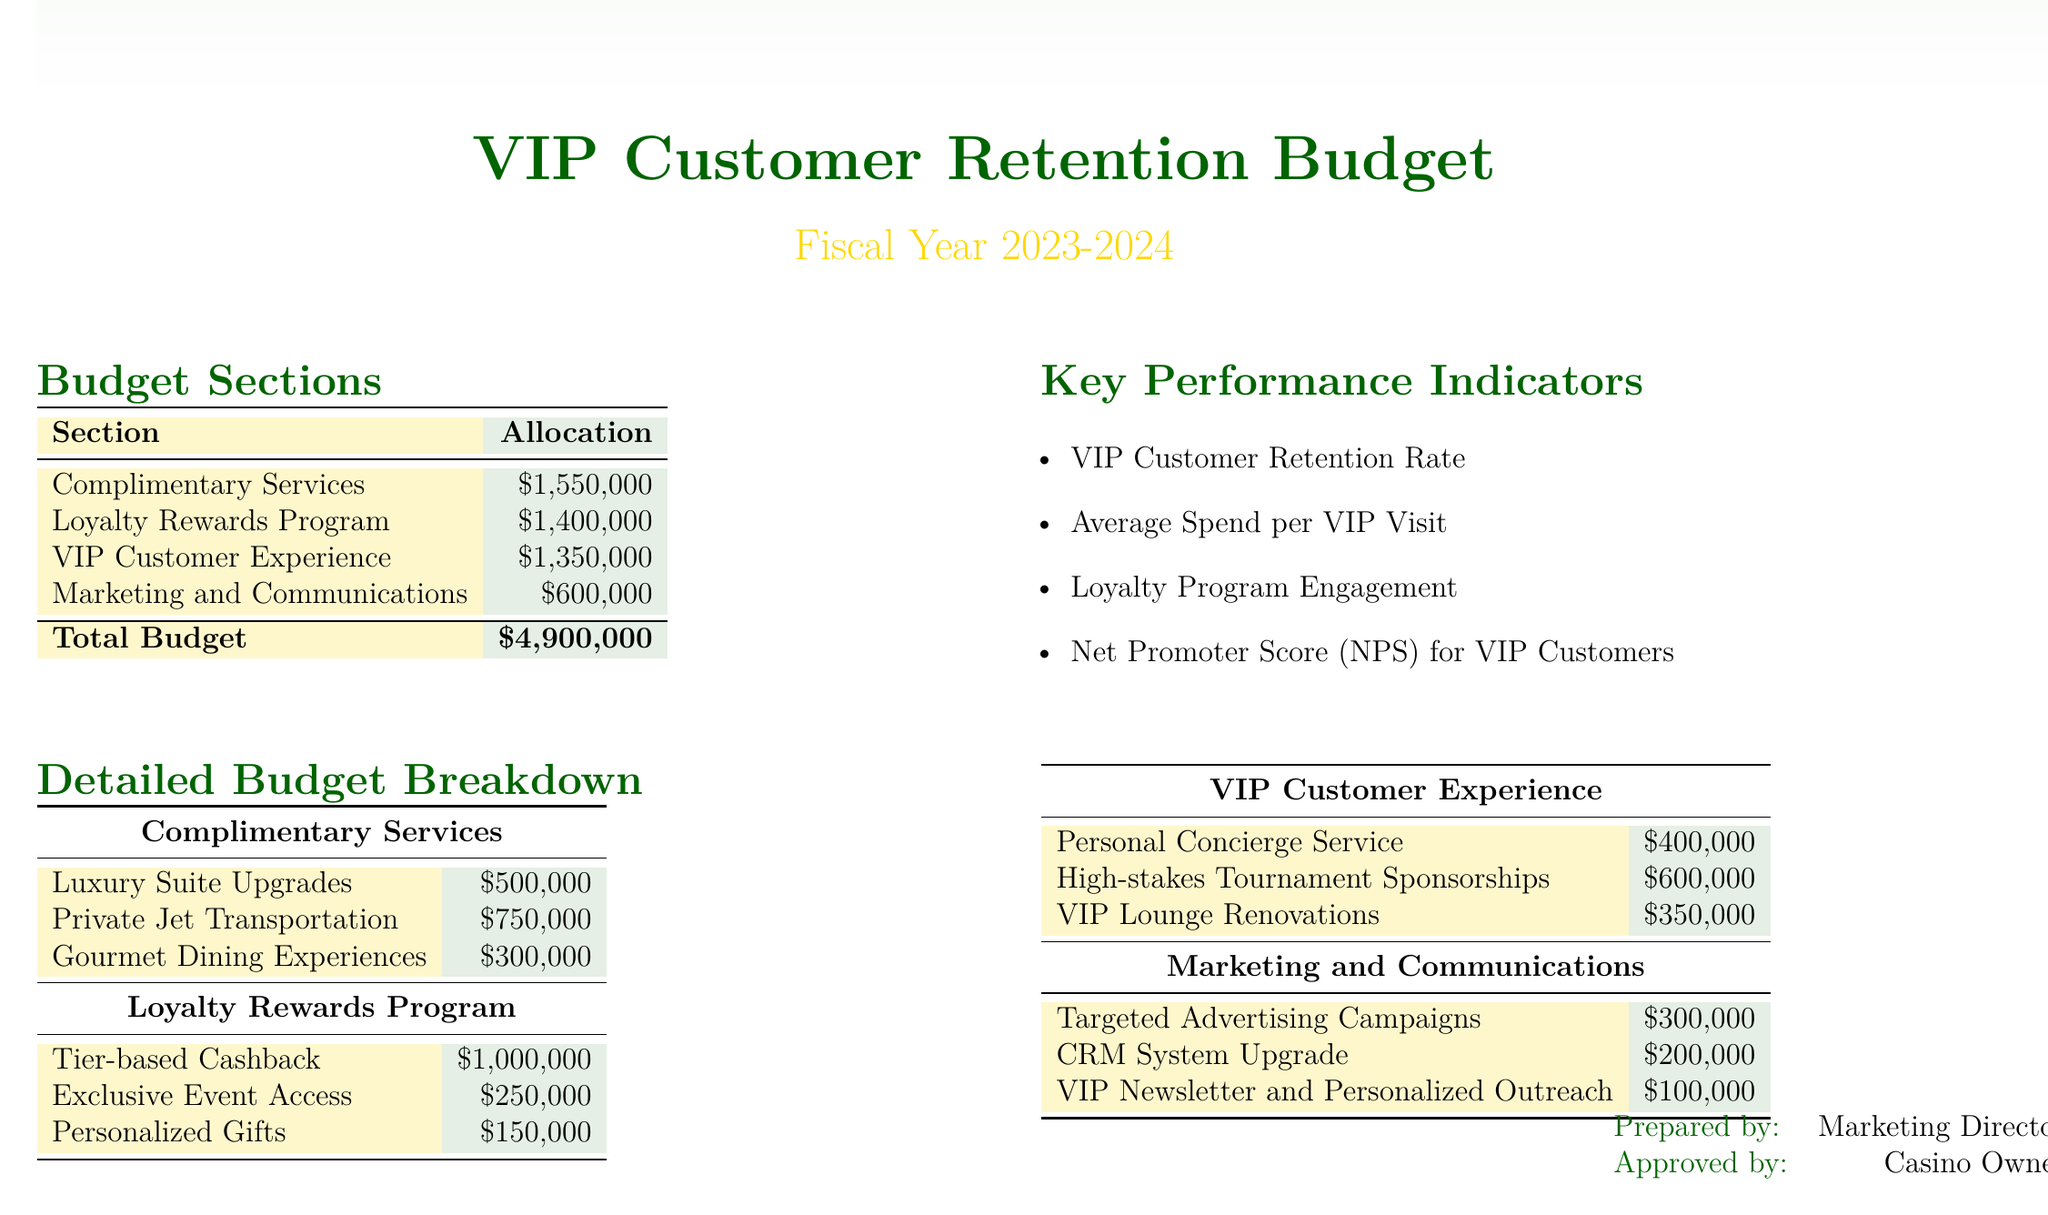What is the total budget for VIP customer retention? The total budget is presented at the end of the budget sections table.
Answer: $4,900,000 How much is allocated for complimentary services? This information is found in the budget sections and shows the funds specifically for complimentary services.
Answer: $1,550,000 What is the budget for the Loyalty Rewards Program? This is listed in the budget sections table, specifically under the Loyalty Rewards Program.
Answer: $1,400,000 What is one of the key performance indicators listed? Key performance indicators are outlined in the key performance indicators section of the document.
Answer: VIP Customer Retention Rate How much is allocated for Private Jet Transportation? This detail is part of the detailed budget breakdown for complimentary services.
Answer: $750,000 What service has the highest allocation in the VIP Customer Experience section? This can be determined by comparing the allocations in the VIP Customer Experience detailed budget breakdown.
Answer: High-stakes Tournament Sponsorships What is the amount set aside for the CRM System Upgrade? The CRM System Upgrade amount is listed in the marketing and communications section of the budget.
Answer: $200,000 How much funding is dedicated to personalized gifts in the Loyalty Rewards Program? The amount for personalized gifts is specified under the detailed budget for the Loyalty Rewards Program.
Answer: $150,000 